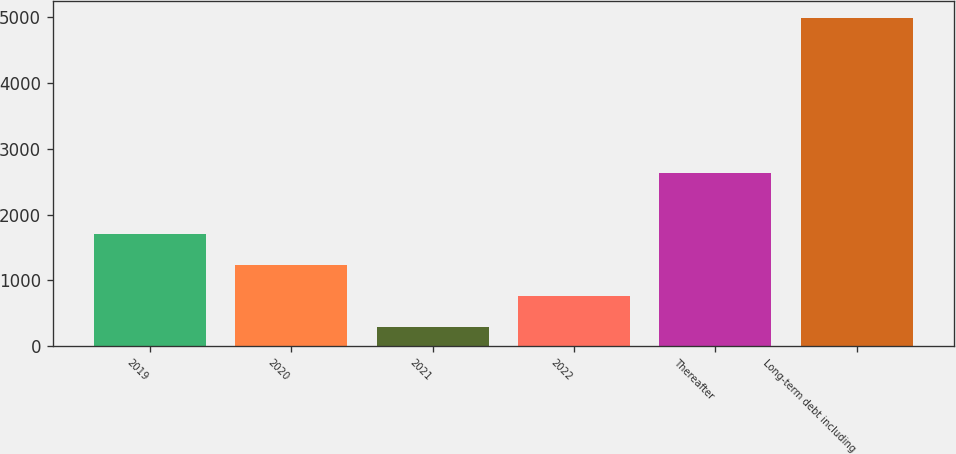Convert chart. <chart><loc_0><loc_0><loc_500><loc_500><bar_chart><fcel>2019<fcel>2020<fcel>2021<fcel>2022<fcel>Thereafter<fcel>Long-term debt including<nl><fcel>1706.5<fcel>1237<fcel>298<fcel>767.5<fcel>2632<fcel>4993<nl></chart> 